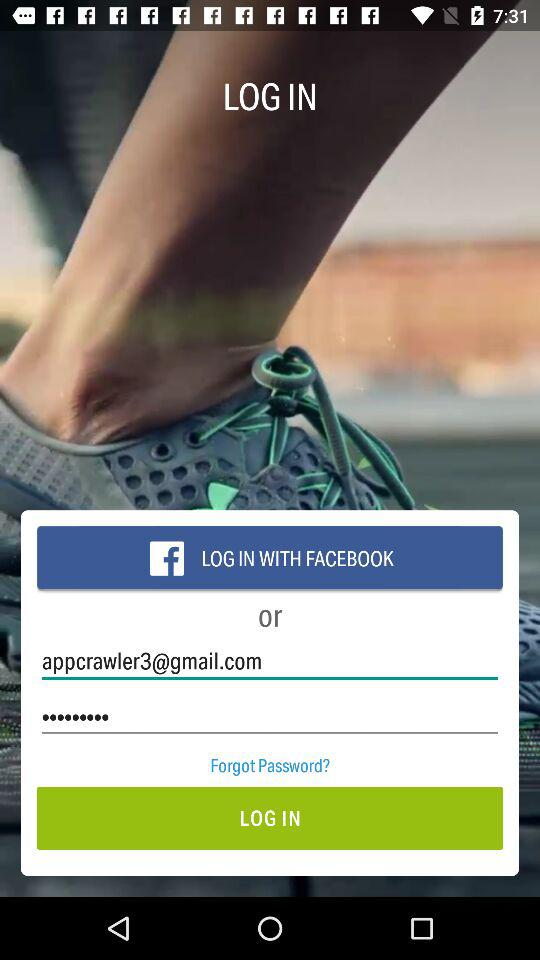Can we reset password?
When the provided information is insufficient, respond with <no answer>. <no answer> 